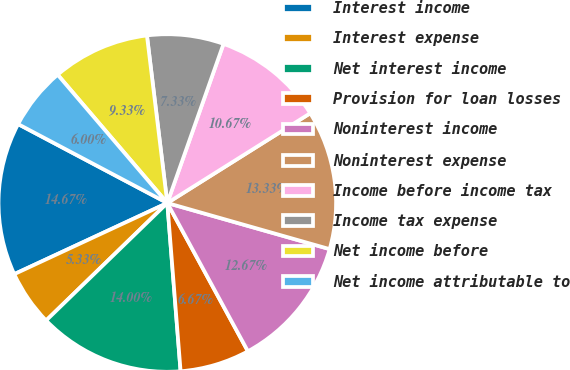<chart> <loc_0><loc_0><loc_500><loc_500><pie_chart><fcel>Interest income<fcel>Interest expense<fcel>Net interest income<fcel>Provision for loan losses<fcel>Noninterest income<fcel>Noninterest expense<fcel>Income before income tax<fcel>Income tax expense<fcel>Net income before<fcel>Net income attributable to<nl><fcel>14.67%<fcel>5.33%<fcel>14.0%<fcel>6.67%<fcel>12.67%<fcel>13.33%<fcel>10.67%<fcel>7.33%<fcel>9.33%<fcel>6.0%<nl></chart> 